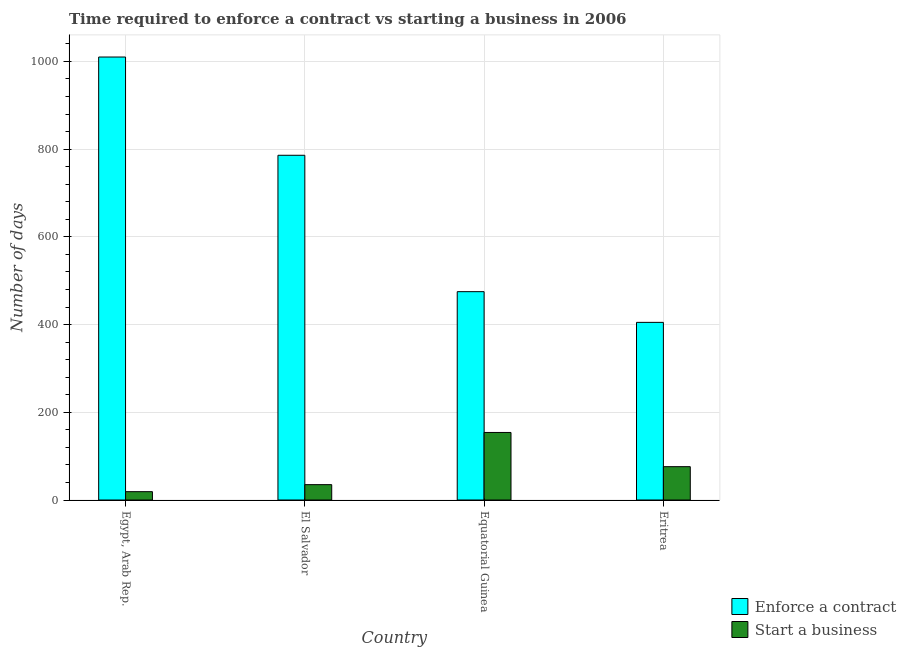How many different coloured bars are there?
Provide a succinct answer. 2. How many groups of bars are there?
Offer a very short reply. 4. Are the number of bars per tick equal to the number of legend labels?
Ensure brevity in your answer.  Yes. Are the number of bars on each tick of the X-axis equal?
Make the answer very short. Yes. How many bars are there on the 2nd tick from the left?
Make the answer very short. 2. What is the label of the 3rd group of bars from the left?
Your answer should be very brief. Equatorial Guinea. What is the number of days to enforece a contract in El Salvador?
Your answer should be very brief. 786. Across all countries, what is the maximum number of days to start a business?
Offer a very short reply. 154. Across all countries, what is the minimum number of days to enforece a contract?
Your answer should be compact. 405. In which country was the number of days to start a business maximum?
Offer a terse response. Equatorial Guinea. In which country was the number of days to enforece a contract minimum?
Provide a succinct answer. Eritrea. What is the total number of days to start a business in the graph?
Provide a succinct answer. 284. What is the difference between the number of days to start a business in El Salvador and that in Eritrea?
Give a very brief answer. -41. What is the difference between the number of days to start a business in Equatorial Guinea and the number of days to enforece a contract in Eritrea?
Ensure brevity in your answer.  -251. What is the difference between the number of days to enforece a contract and number of days to start a business in Equatorial Guinea?
Keep it short and to the point. 321. What is the ratio of the number of days to start a business in El Salvador to that in Equatorial Guinea?
Provide a succinct answer. 0.23. Is the number of days to start a business in El Salvador less than that in Equatorial Guinea?
Your answer should be compact. Yes. Is the difference between the number of days to enforece a contract in Egypt, Arab Rep. and Eritrea greater than the difference between the number of days to start a business in Egypt, Arab Rep. and Eritrea?
Keep it short and to the point. Yes. What is the difference between the highest and the second highest number of days to enforece a contract?
Your answer should be compact. 224. What is the difference between the highest and the lowest number of days to enforece a contract?
Offer a very short reply. 605. Is the sum of the number of days to enforece a contract in Egypt, Arab Rep. and El Salvador greater than the maximum number of days to start a business across all countries?
Make the answer very short. Yes. What does the 1st bar from the left in El Salvador represents?
Your answer should be compact. Enforce a contract. What does the 1st bar from the right in El Salvador represents?
Offer a very short reply. Start a business. Are the values on the major ticks of Y-axis written in scientific E-notation?
Provide a succinct answer. No. Does the graph contain grids?
Ensure brevity in your answer.  Yes. Where does the legend appear in the graph?
Your answer should be very brief. Bottom right. What is the title of the graph?
Keep it short and to the point. Time required to enforce a contract vs starting a business in 2006. Does "Male" appear as one of the legend labels in the graph?
Your answer should be very brief. No. What is the label or title of the X-axis?
Your response must be concise. Country. What is the label or title of the Y-axis?
Keep it short and to the point. Number of days. What is the Number of days in Enforce a contract in Egypt, Arab Rep.?
Keep it short and to the point. 1010. What is the Number of days of Start a business in Egypt, Arab Rep.?
Provide a short and direct response. 19. What is the Number of days in Enforce a contract in El Salvador?
Make the answer very short. 786. What is the Number of days in Enforce a contract in Equatorial Guinea?
Offer a terse response. 475. What is the Number of days of Start a business in Equatorial Guinea?
Your answer should be very brief. 154. What is the Number of days of Enforce a contract in Eritrea?
Your response must be concise. 405. What is the Number of days of Start a business in Eritrea?
Your answer should be very brief. 76. Across all countries, what is the maximum Number of days of Enforce a contract?
Give a very brief answer. 1010. Across all countries, what is the maximum Number of days of Start a business?
Ensure brevity in your answer.  154. Across all countries, what is the minimum Number of days of Enforce a contract?
Your answer should be compact. 405. What is the total Number of days of Enforce a contract in the graph?
Provide a succinct answer. 2676. What is the total Number of days of Start a business in the graph?
Offer a very short reply. 284. What is the difference between the Number of days in Enforce a contract in Egypt, Arab Rep. and that in El Salvador?
Provide a succinct answer. 224. What is the difference between the Number of days of Enforce a contract in Egypt, Arab Rep. and that in Equatorial Guinea?
Give a very brief answer. 535. What is the difference between the Number of days of Start a business in Egypt, Arab Rep. and that in Equatorial Guinea?
Give a very brief answer. -135. What is the difference between the Number of days in Enforce a contract in Egypt, Arab Rep. and that in Eritrea?
Your answer should be compact. 605. What is the difference between the Number of days in Start a business in Egypt, Arab Rep. and that in Eritrea?
Provide a short and direct response. -57. What is the difference between the Number of days of Enforce a contract in El Salvador and that in Equatorial Guinea?
Make the answer very short. 311. What is the difference between the Number of days of Start a business in El Salvador and that in Equatorial Guinea?
Your response must be concise. -119. What is the difference between the Number of days of Enforce a contract in El Salvador and that in Eritrea?
Your response must be concise. 381. What is the difference between the Number of days of Start a business in El Salvador and that in Eritrea?
Your answer should be compact. -41. What is the difference between the Number of days in Enforce a contract in Equatorial Guinea and that in Eritrea?
Ensure brevity in your answer.  70. What is the difference between the Number of days in Enforce a contract in Egypt, Arab Rep. and the Number of days in Start a business in El Salvador?
Keep it short and to the point. 975. What is the difference between the Number of days of Enforce a contract in Egypt, Arab Rep. and the Number of days of Start a business in Equatorial Guinea?
Offer a terse response. 856. What is the difference between the Number of days in Enforce a contract in Egypt, Arab Rep. and the Number of days in Start a business in Eritrea?
Your response must be concise. 934. What is the difference between the Number of days in Enforce a contract in El Salvador and the Number of days in Start a business in Equatorial Guinea?
Your answer should be compact. 632. What is the difference between the Number of days of Enforce a contract in El Salvador and the Number of days of Start a business in Eritrea?
Provide a short and direct response. 710. What is the difference between the Number of days in Enforce a contract in Equatorial Guinea and the Number of days in Start a business in Eritrea?
Your response must be concise. 399. What is the average Number of days of Enforce a contract per country?
Ensure brevity in your answer.  669. What is the difference between the Number of days in Enforce a contract and Number of days in Start a business in Egypt, Arab Rep.?
Your answer should be very brief. 991. What is the difference between the Number of days in Enforce a contract and Number of days in Start a business in El Salvador?
Your answer should be very brief. 751. What is the difference between the Number of days of Enforce a contract and Number of days of Start a business in Equatorial Guinea?
Your response must be concise. 321. What is the difference between the Number of days of Enforce a contract and Number of days of Start a business in Eritrea?
Ensure brevity in your answer.  329. What is the ratio of the Number of days in Enforce a contract in Egypt, Arab Rep. to that in El Salvador?
Keep it short and to the point. 1.28. What is the ratio of the Number of days in Start a business in Egypt, Arab Rep. to that in El Salvador?
Provide a short and direct response. 0.54. What is the ratio of the Number of days of Enforce a contract in Egypt, Arab Rep. to that in Equatorial Guinea?
Ensure brevity in your answer.  2.13. What is the ratio of the Number of days in Start a business in Egypt, Arab Rep. to that in Equatorial Guinea?
Provide a short and direct response. 0.12. What is the ratio of the Number of days in Enforce a contract in Egypt, Arab Rep. to that in Eritrea?
Keep it short and to the point. 2.49. What is the ratio of the Number of days in Start a business in Egypt, Arab Rep. to that in Eritrea?
Offer a very short reply. 0.25. What is the ratio of the Number of days of Enforce a contract in El Salvador to that in Equatorial Guinea?
Give a very brief answer. 1.65. What is the ratio of the Number of days in Start a business in El Salvador to that in Equatorial Guinea?
Make the answer very short. 0.23. What is the ratio of the Number of days in Enforce a contract in El Salvador to that in Eritrea?
Your response must be concise. 1.94. What is the ratio of the Number of days of Start a business in El Salvador to that in Eritrea?
Make the answer very short. 0.46. What is the ratio of the Number of days of Enforce a contract in Equatorial Guinea to that in Eritrea?
Give a very brief answer. 1.17. What is the ratio of the Number of days in Start a business in Equatorial Guinea to that in Eritrea?
Your response must be concise. 2.03. What is the difference between the highest and the second highest Number of days in Enforce a contract?
Make the answer very short. 224. What is the difference between the highest and the second highest Number of days of Start a business?
Make the answer very short. 78. What is the difference between the highest and the lowest Number of days in Enforce a contract?
Provide a succinct answer. 605. What is the difference between the highest and the lowest Number of days in Start a business?
Give a very brief answer. 135. 